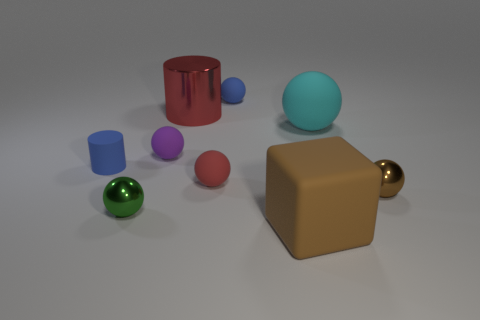Subtract all big balls. How many balls are left? 5 Subtract 4 spheres. How many spheres are left? 2 Subtract all green balls. How many balls are left? 5 Subtract all spheres. How many objects are left? 3 Subtract all purple balls. Subtract all brown cylinders. How many balls are left? 5 Subtract all large gray metallic cylinders. Subtract all large blocks. How many objects are left? 8 Add 6 green balls. How many green balls are left? 7 Add 6 big green metallic cylinders. How many big green metallic cylinders exist? 6 Subtract 1 brown spheres. How many objects are left? 8 